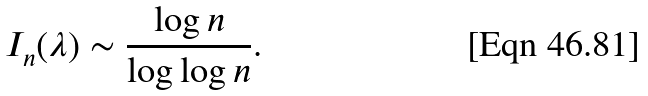<formula> <loc_0><loc_0><loc_500><loc_500>I _ { n } ( \lambda ) \sim { \frac { \log n } { \log \log n } } .</formula> 